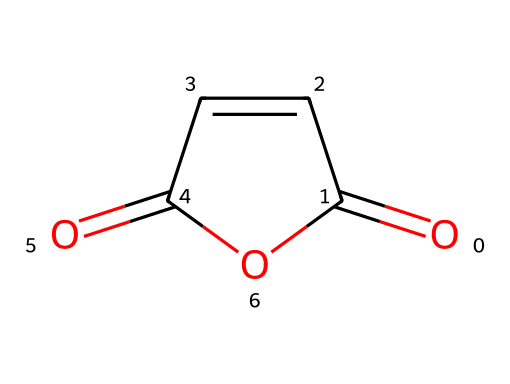What is the molecular formula of maleic anhydride? By analyzing the SMILES representation, O=C1C=CC(=O)O1 indicates the presence of 4 carbon atoms (C), 4 hydrogen atoms (H), and 3 oxygen atoms (O). Therefore, the molecular formula can be derived as C4H2O3.
Answer: C4H2O3 How many rings are present in the structure of maleic anhydride? The depiction of the structure in the SMILES suggests a cyclic structure because of the presence of the "C1...O1" label, which indicates the start and end of a ring. Therefore, there is one ring in maleic anhydride.
Answer: 1 What type of functional group is present in maleic anhydride? By examining the structure represented, maleic anhydride contains an anhydride functional group, which is characterized by the presence of two carbonyl groups (C=O) linked to the same oxygen atom.
Answer: anhydride What is the total count of carbonyl groups in maleic anhydride? In the SMILES, the presence of "C=O" indicates carbonyl groups. Here, there are two instances of carbonyls depicted (two "C=O" appearances). Hence, the total count of carbonyl groups is 2.
Answer: 2 What is the hybridization of the carbon atoms in the double bond of maleic anhydride? In the maleic anhydride structure, the carbon atoms involved in the double bond (C=C) have sp2 hybridization as they each are bonded to another carbon atom and one hydrogen atom while having one double bond.
Answer: sp2 What is the characteristic odor of maleic anhydride? Maleic anhydride typically has a sharp, acrid odor, which is often described as irritating. This characteristic can be attributed to its anhydride nature and the presence of carbonyl groups.
Answer: acrid 